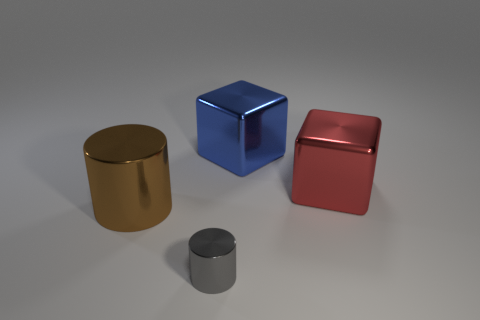What number of other things are there of the same shape as the large blue object?
Your answer should be compact. 1. What number of cyan objects are either large things or large rubber balls?
Offer a very short reply. 0. Does the cylinder behind the gray metallic object have the same color as the small cylinder?
Your response must be concise. No. What is the shape of the brown thing that is the same material as the large blue block?
Give a very brief answer. Cylinder. There is a metal object that is both behind the tiny shiny cylinder and in front of the large red object; what color is it?
Offer a very short reply. Brown. There is a shiny cube on the left side of the big object right of the large blue block; what size is it?
Provide a short and direct response. Large. Are there any cubes that have the same color as the small shiny thing?
Give a very brief answer. No. Are there an equal number of blue metallic cubes behind the big blue thing and large red objects?
Your answer should be very brief. No. What number of red metal cylinders are there?
Provide a succinct answer. 0. The big shiny object that is left of the large red block and behind the big cylinder has what shape?
Provide a short and direct response. Cube. 